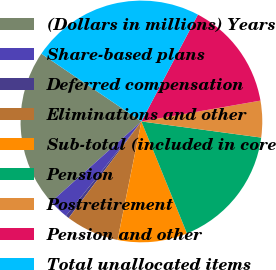Convert chart. <chart><loc_0><loc_0><loc_500><loc_500><pie_chart><fcel>(Dollars in millions) Years<fcel>Share-based plans<fcel>Deferred compensation<fcel>Eliminations and other<fcel>Sub-total (included in core<fcel>Pension<fcel>Postretirement<fcel>Pension and other<fcel>Total unallocated items<nl><fcel>21.06%<fcel>2.68%<fcel>0.46%<fcel>7.11%<fcel>9.32%<fcel>16.72%<fcel>4.89%<fcel>14.5%<fcel>23.27%<nl></chart> 